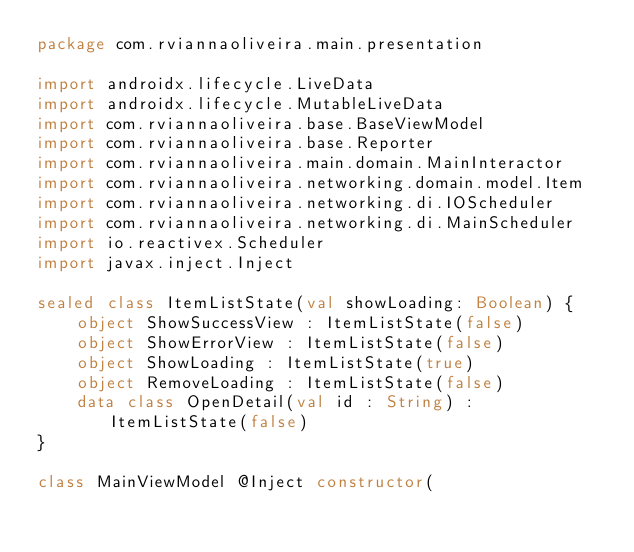<code> <loc_0><loc_0><loc_500><loc_500><_Kotlin_>package com.rviannaoliveira.main.presentation

import androidx.lifecycle.LiveData
import androidx.lifecycle.MutableLiveData
import com.rviannaoliveira.base.BaseViewModel
import com.rviannaoliveira.base.Reporter
import com.rviannaoliveira.main.domain.MainInteractor
import com.rviannaoliveira.networking.domain.model.Item
import com.rviannaoliveira.networking.di.IOScheduler
import com.rviannaoliveira.networking.di.MainScheduler
import io.reactivex.Scheduler
import javax.inject.Inject

sealed class ItemListState(val showLoading: Boolean) {
    object ShowSuccessView : ItemListState(false)
    object ShowErrorView : ItemListState(false)
    object ShowLoading : ItemListState(true)
    object RemoveLoading : ItemListState(false)
    data class OpenDetail(val id : String) : ItemListState(false)
}

class MainViewModel @Inject constructor(</code> 